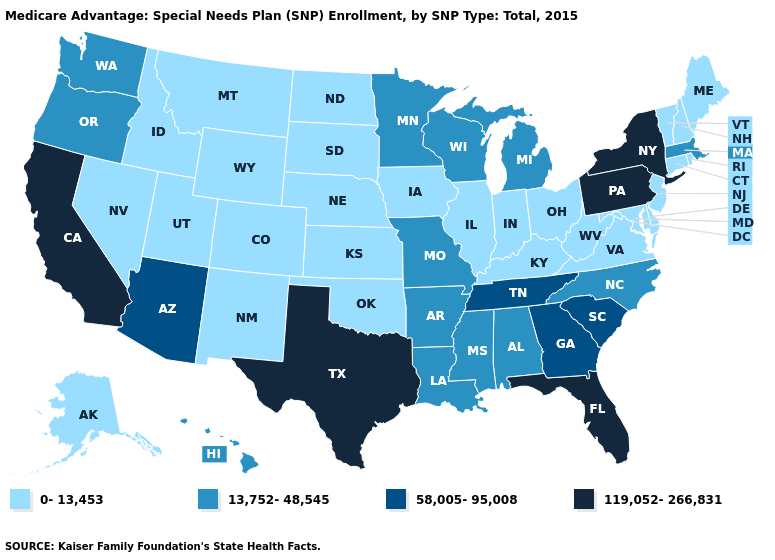Name the states that have a value in the range 58,005-95,008?
Write a very short answer. Arizona, Georgia, South Carolina, Tennessee. Name the states that have a value in the range 0-13,453?
Be succinct. Alaska, Colorado, Connecticut, Delaware, Iowa, Idaho, Illinois, Indiana, Kansas, Kentucky, Maryland, Maine, Montana, North Dakota, Nebraska, New Hampshire, New Jersey, New Mexico, Nevada, Ohio, Oklahoma, Rhode Island, South Dakota, Utah, Virginia, Vermont, West Virginia, Wyoming. Which states have the lowest value in the Northeast?
Short answer required. Connecticut, Maine, New Hampshire, New Jersey, Rhode Island, Vermont. Does Pennsylvania have a higher value than Texas?
Be succinct. No. Does New Mexico have the lowest value in the West?
Be succinct. Yes. Among the states that border Virginia , which have the lowest value?
Give a very brief answer. Kentucky, Maryland, West Virginia. Among the states that border Louisiana , which have the lowest value?
Quick response, please. Arkansas, Mississippi. Is the legend a continuous bar?
Write a very short answer. No. Does Massachusetts have the lowest value in the Northeast?
Quick response, please. No. What is the value of South Dakota?
Quick response, please. 0-13,453. Name the states that have a value in the range 58,005-95,008?
Answer briefly. Arizona, Georgia, South Carolina, Tennessee. What is the value of Wisconsin?
Write a very short answer. 13,752-48,545. What is the value of New Mexico?
Keep it brief. 0-13,453. Among the states that border Nevada , does Oregon have the lowest value?
Be succinct. No. What is the value of South Carolina?
Keep it brief. 58,005-95,008. 